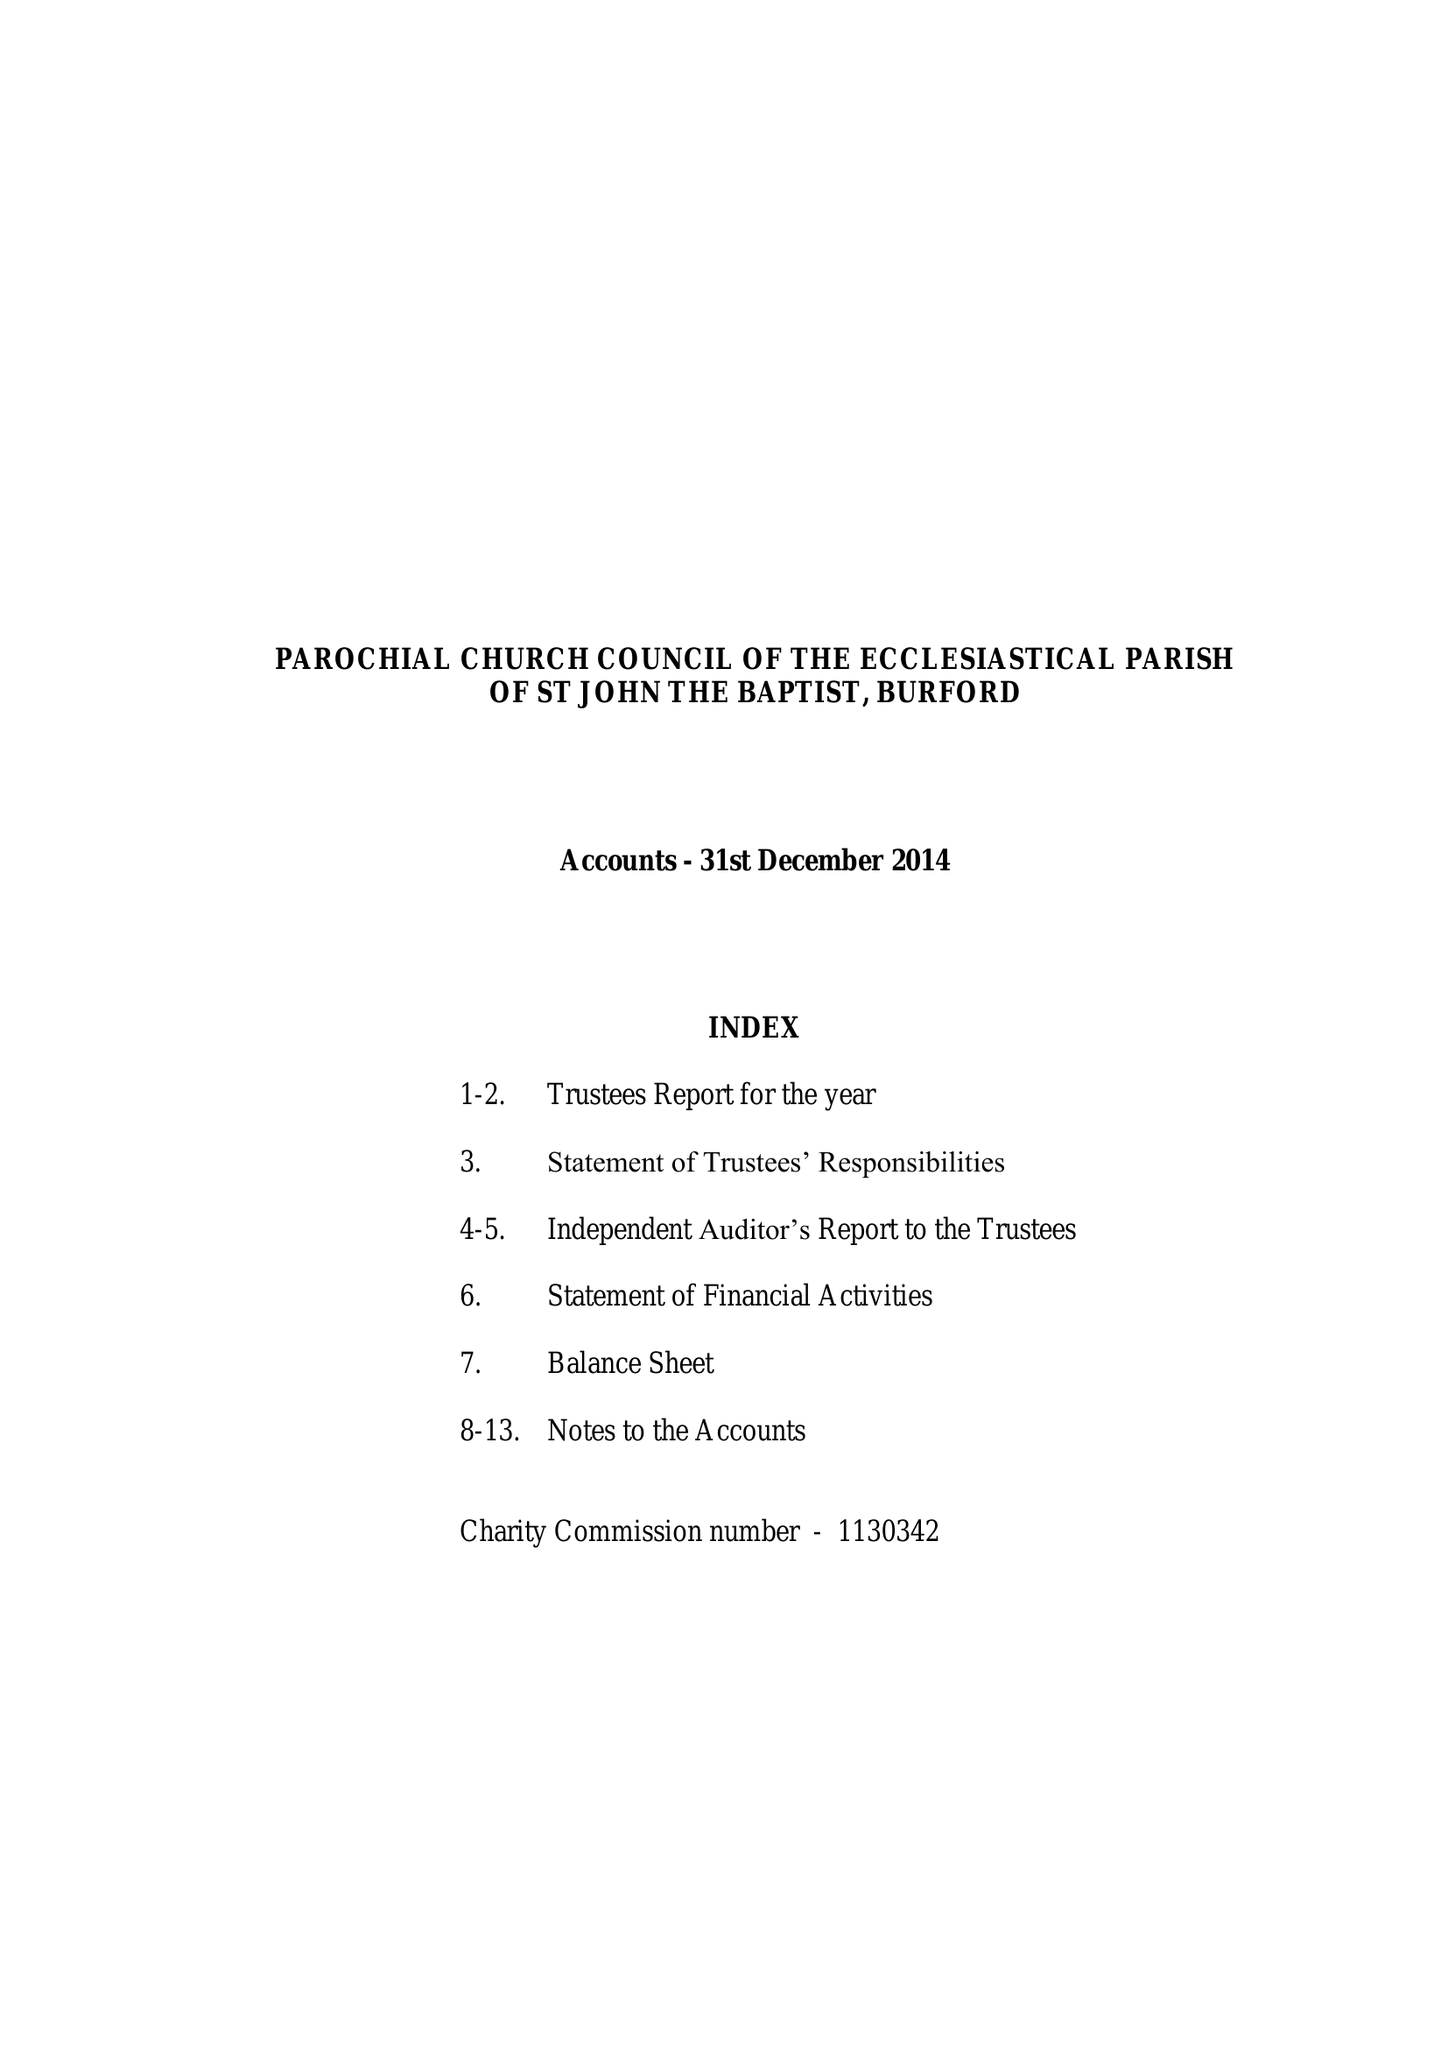What is the value for the income_annually_in_british_pounds?
Answer the question using a single word or phrase. 1035577.00 